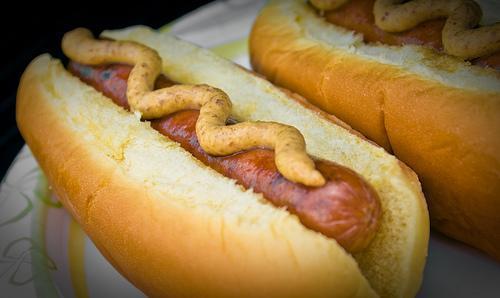How many hot dogs are in the photo?
Give a very brief answer. 2. How many people crossing the street have grocery bags?
Give a very brief answer. 0. 